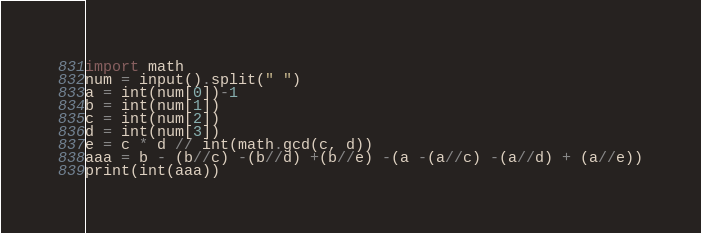<code> <loc_0><loc_0><loc_500><loc_500><_Python_>import math
num = input().split(" ")
a = int(num[0])-1
b = int(num[1])
c = int(num[2])
d = int(num[3])
e = c * d // int(math.gcd(c, d))
aaa = b - (b//c) -(b//d) +(b//e) -(a -(a//c) -(a//d) + (a//e))
print(int(aaa))</code> 